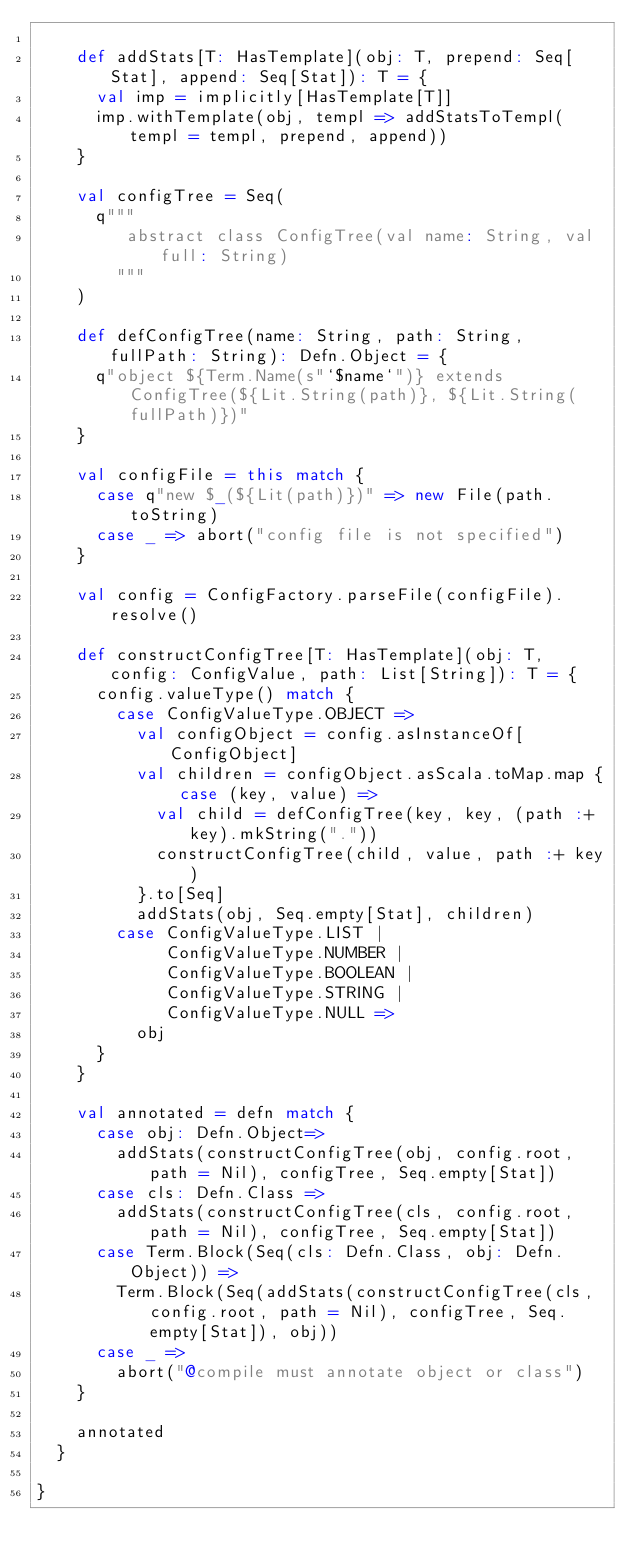Convert code to text. <code><loc_0><loc_0><loc_500><loc_500><_Scala_>
    def addStats[T: HasTemplate](obj: T, prepend: Seq[Stat], append: Seq[Stat]): T = {
      val imp = implicitly[HasTemplate[T]]
      imp.withTemplate(obj, templ => addStatsToTempl(templ = templ, prepend, append))
    }

    val configTree = Seq(
      q"""
         abstract class ConfigTree(val name: String, val full: String)
        """
    )

    def defConfigTree(name: String, path: String, fullPath: String): Defn.Object = {
      q"object ${Term.Name(s"`$name`")} extends ConfigTree(${Lit.String(path)}, ${Lit.String(fullPath)})"
    }

    val configFile = this match {
      case q"new $_(${Lit(path)})" => new File(path.toString)
      case _ => abort("config file is not specified")
    }

    val config = ConfigFactory.parseFile(configFile).resolve()

    def constructConfigTree[T: HasTemplate](obj: T, config: ConfigValue, path: List[String]): T = {
      config.valueType() match {
        case ConfigValueType.OBJECT =>
          val configObject = config.asInstanceOf[ConfigObject]
          val children = configObject.asScala.toMap.map { case (key, value) =>
            val child = defConfigTree(key, key, (path :+ key).mkString("."))
            constructConfigTree(child, value, path :+ key)
          }.to[Seq]
          addStats(obj, Seq.empty[Stat], children)
        case ConfigValueType.LIST |
             ConfigValueType.NUMBER |
             ConfigValueType.BOOLEAN |
             ConfigValueType.STRING |
             ConfigValueType.NULL =>
          obj
      }
    }

    val annotated = defn match {
      case obj: Defn.Object=>
        addStats(constructConfigTree(obj, config.root, path = Nil), configTree, Seq.empty[Stat])
      case cls: Defn.Class =>
        addStats(constructConfigTree(cls, config.root, path = Nil), configTree, Seq.empty[Stat])
      case Term.Block(Seq(cls: Defn.Class, obj: Defn.Object)) =>
        Term.Block(Seq(addStats(constructConfigTree(cls, config.root, path = Nil), configTree, Seq.empty[Stat]), obj))
      case _ =>
        abort("@compile must annotate object or class")
    }

    annotated
  }

}
</code> 